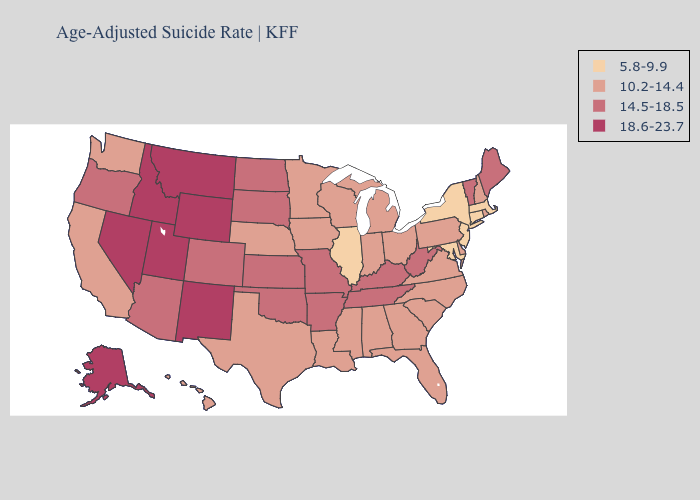Is the legend a continuous bar?
Quick response, please. No. What is the highest value in the MidWest ?
Answer briefly. 14.5-18.5. Name the states that have a value in the range 18.6-23.7?
Answer briefly. Alaska, Idaho, Montana, Nevada, New Mexico, Utah, Wyoming. Name the states that have a value in the range 14.5-18.5?
Be succinct. Arizona, Arkansas, Colorado, Kansas, Kentucky, Maine, Missouri, North Dakota, Oklahoma, Oregon, South Dakota, Tennessee, Vermont, West Virginia. Which states have the lowest value in the USA?
Write a very short answer. Connecticut, Illinois, Maryland, Massachusetts, New Jersey, New York. Name the states that have a value in the range 18.6-23.7?
Short answer required. Alaska, Idaho, Montana, Nevada, New Mexico, Utah, Wyoming. What is the value of Utah?
Short answer required. 18.6-23.7. Which states have the lowest value in the USA?
Short answer required. Connecticut, Illinois, Maryland, Massachusetts, New Jersey, New York. Which states have the lowest value in the West?
Keep it brief. California, Hawaii, Washington. Which states have the lowest value in the USA?
Answer briefly. Connecticut, Illinois, Maryland, Massachusetts, New Jersey, New York. Which states have the lowest value in the USA?
Short answer required. Connecticut, Illinois, Maryland, Massachusetts, New Jersey, New York. Does Hawaii have the same value as Arkansas?
Write a very short answer. No. Name the states that have a value in the range 18.6-23.7?
Answer briefly. Alaska, Idaho, Montana, Nevada, New Mexico, Utah, Wyoming. What is the value of Virginia?
Answer briefly. 10.2-14.4. What is the value of Washington?
Give a very brief answer. 10.2-14.4. 